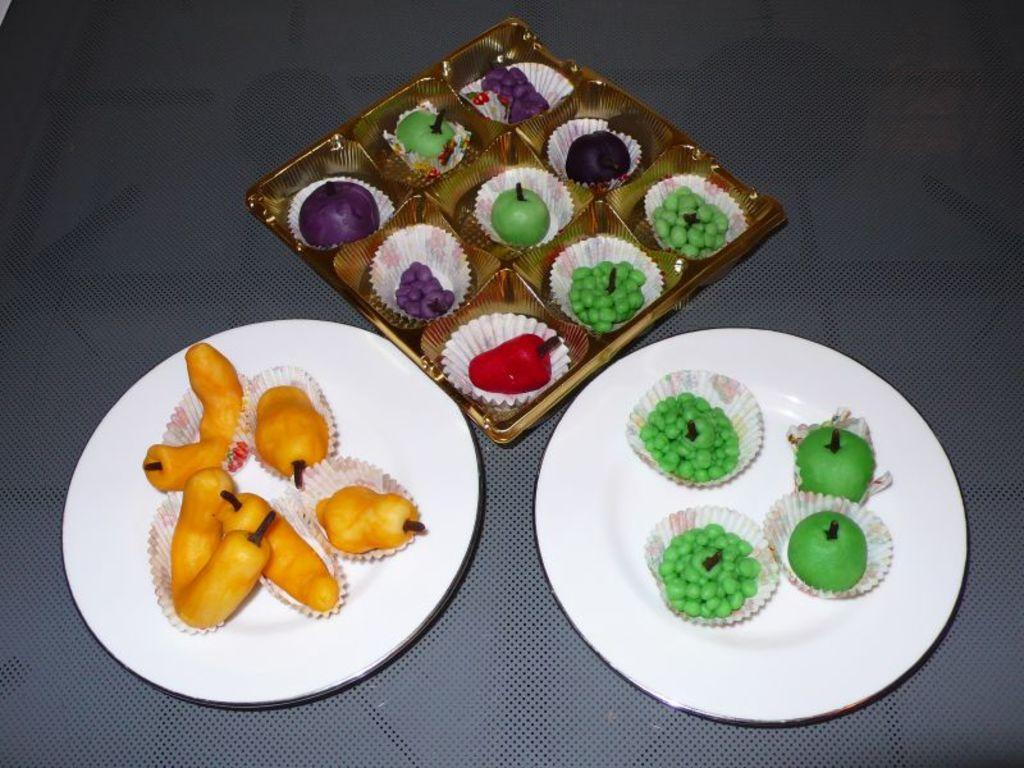How many plates can be seen in the image? There are two plates in the image. What else is present in the image besides the plates? There is a box in the image. What is inside the box? The box contains food items in wrappers. What is the color of the surface on which the items are placed? The items are placed on a blue surface. What type of boats are visible in the image? There are no boats present in the image. What kind of powder is being used to prepare the food items in the image? There is no powder mentioned or visible in the image; the food items are in wrappers. 